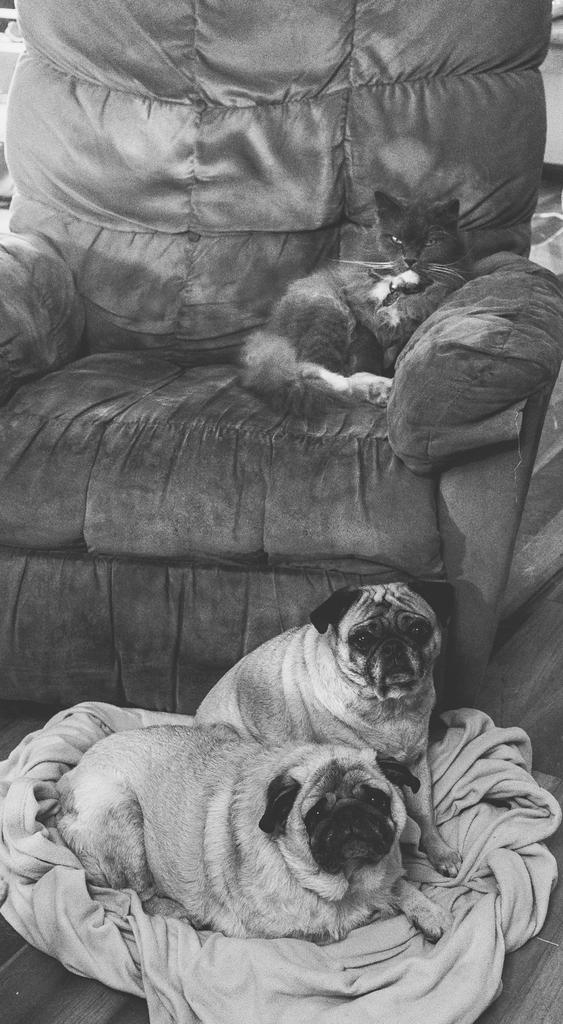What type of picture is in the image? The image contains a black and white picture. What animals are featured in the black and white picture? There are two dogs in the black and white picture. What is the dogs' location in the picture? The dogs are on a cloth in the picture. What type of furniture is in the image? There is a couch in the image. What other animal is present in the image? There is a black cat on the couch. How many boots are visible in the image? There are no boots present in the image. What type of twist can be seen in the image? There is no twist visible in the image. 